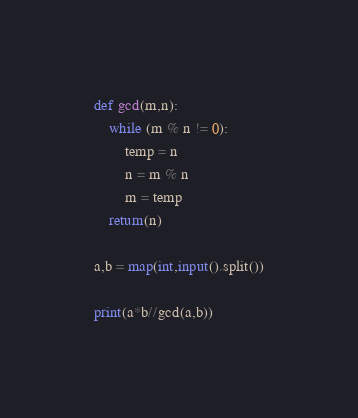Convert code to text. <code><loc_0><loc_0><loc_500><loc_500><_Python_>def gcd(m,n):
    while (m % n != 0):
        temp = n
        n = m % n
        m = temp
    return(n)

a,b = map(int,input().split())

print(a*b//gcd(a,b))</code> 